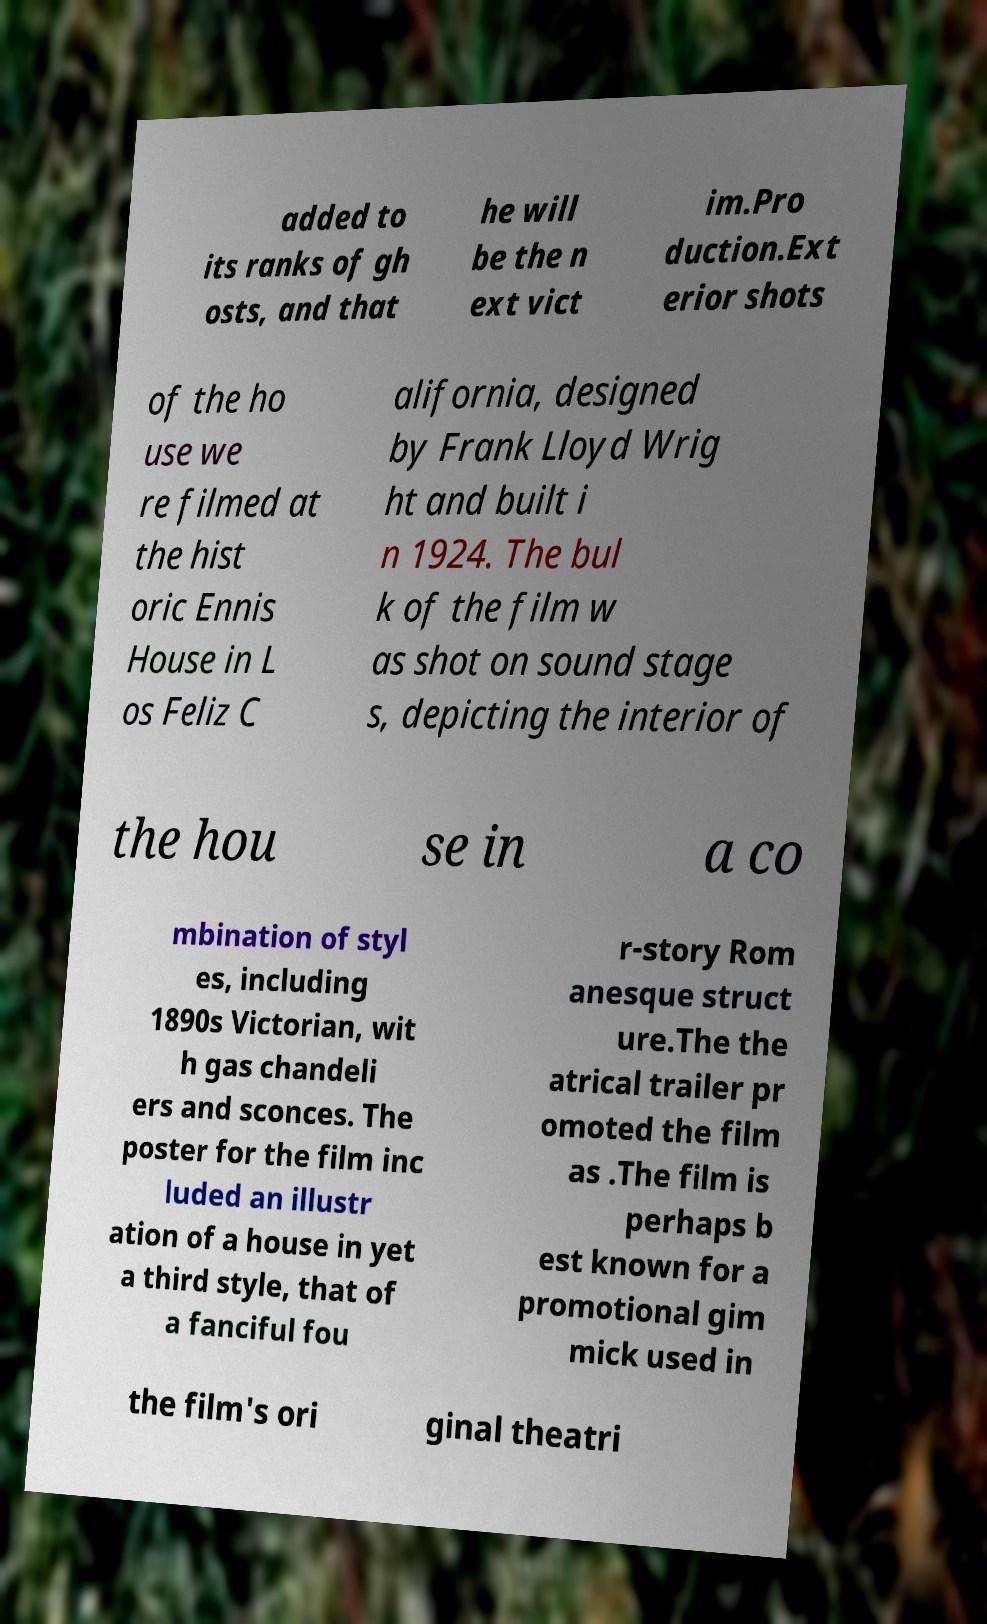Can you accurately transcribe the text from the provided image for me? added to its ranks of gh osts, and that he will be the n ext vict im.Pro duction.Ext erior shots of the ho use we re filmed at the hist oric Ennis House in L os Feliz C alifornia, designed by Frank Lloyd Wrig ht and built i n 1924. The bul k of the film w as shot on sound stage s, depicting the interior of the hou se in a co mbination of styl es, including 1890s Victorian, wit h gas chandeli ers and sconces. The poster for the film inc luded an illustr ation of a house in yet a third style, that of a fanciful fou r-story Rom anesque struct ure.The the atrical trailer pr omoted the film as .The film is perhaps b est known for a promotional gim mick used in the film's ori ginal theatri 